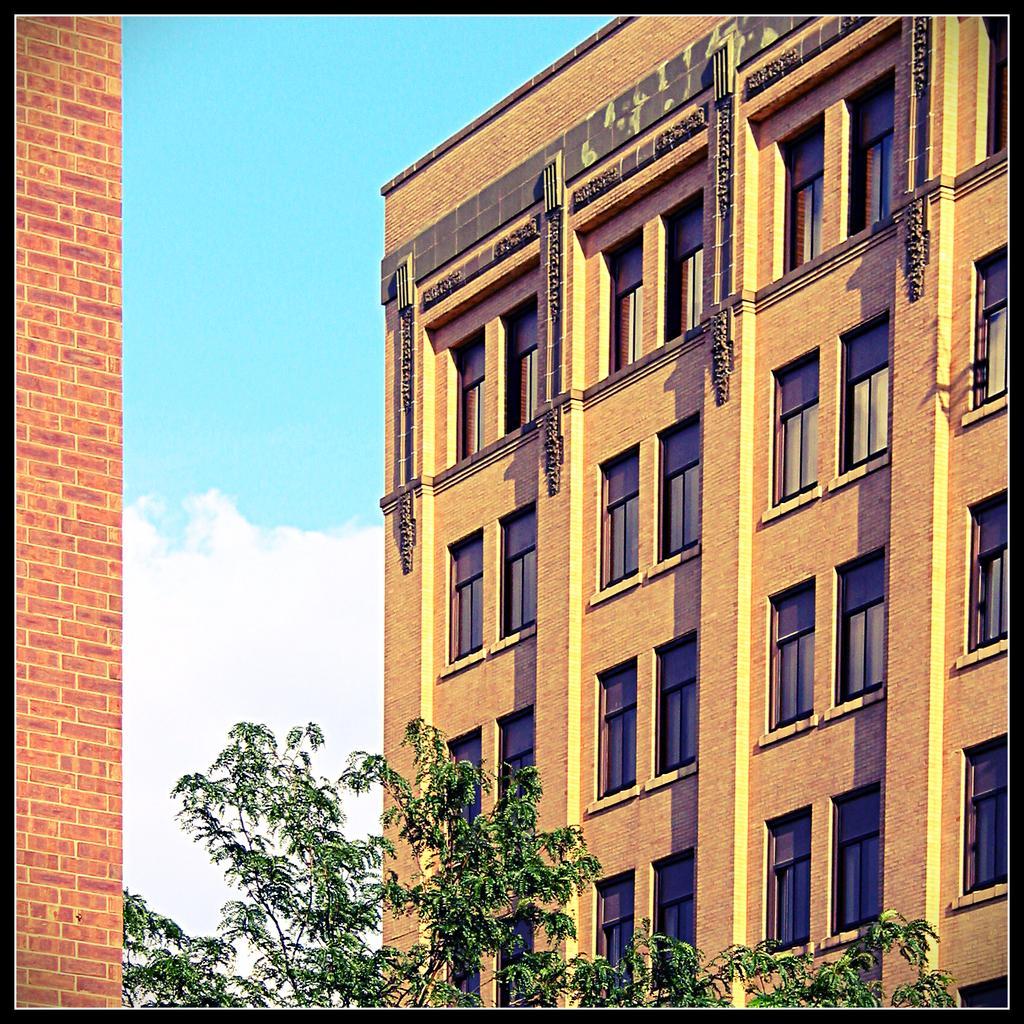Describe this image in one or two sentences. In this picture I can observe building in the middle of the picture. In the bottom of the picture I can observe trees. In the background I can observe some clouds in the sky. 